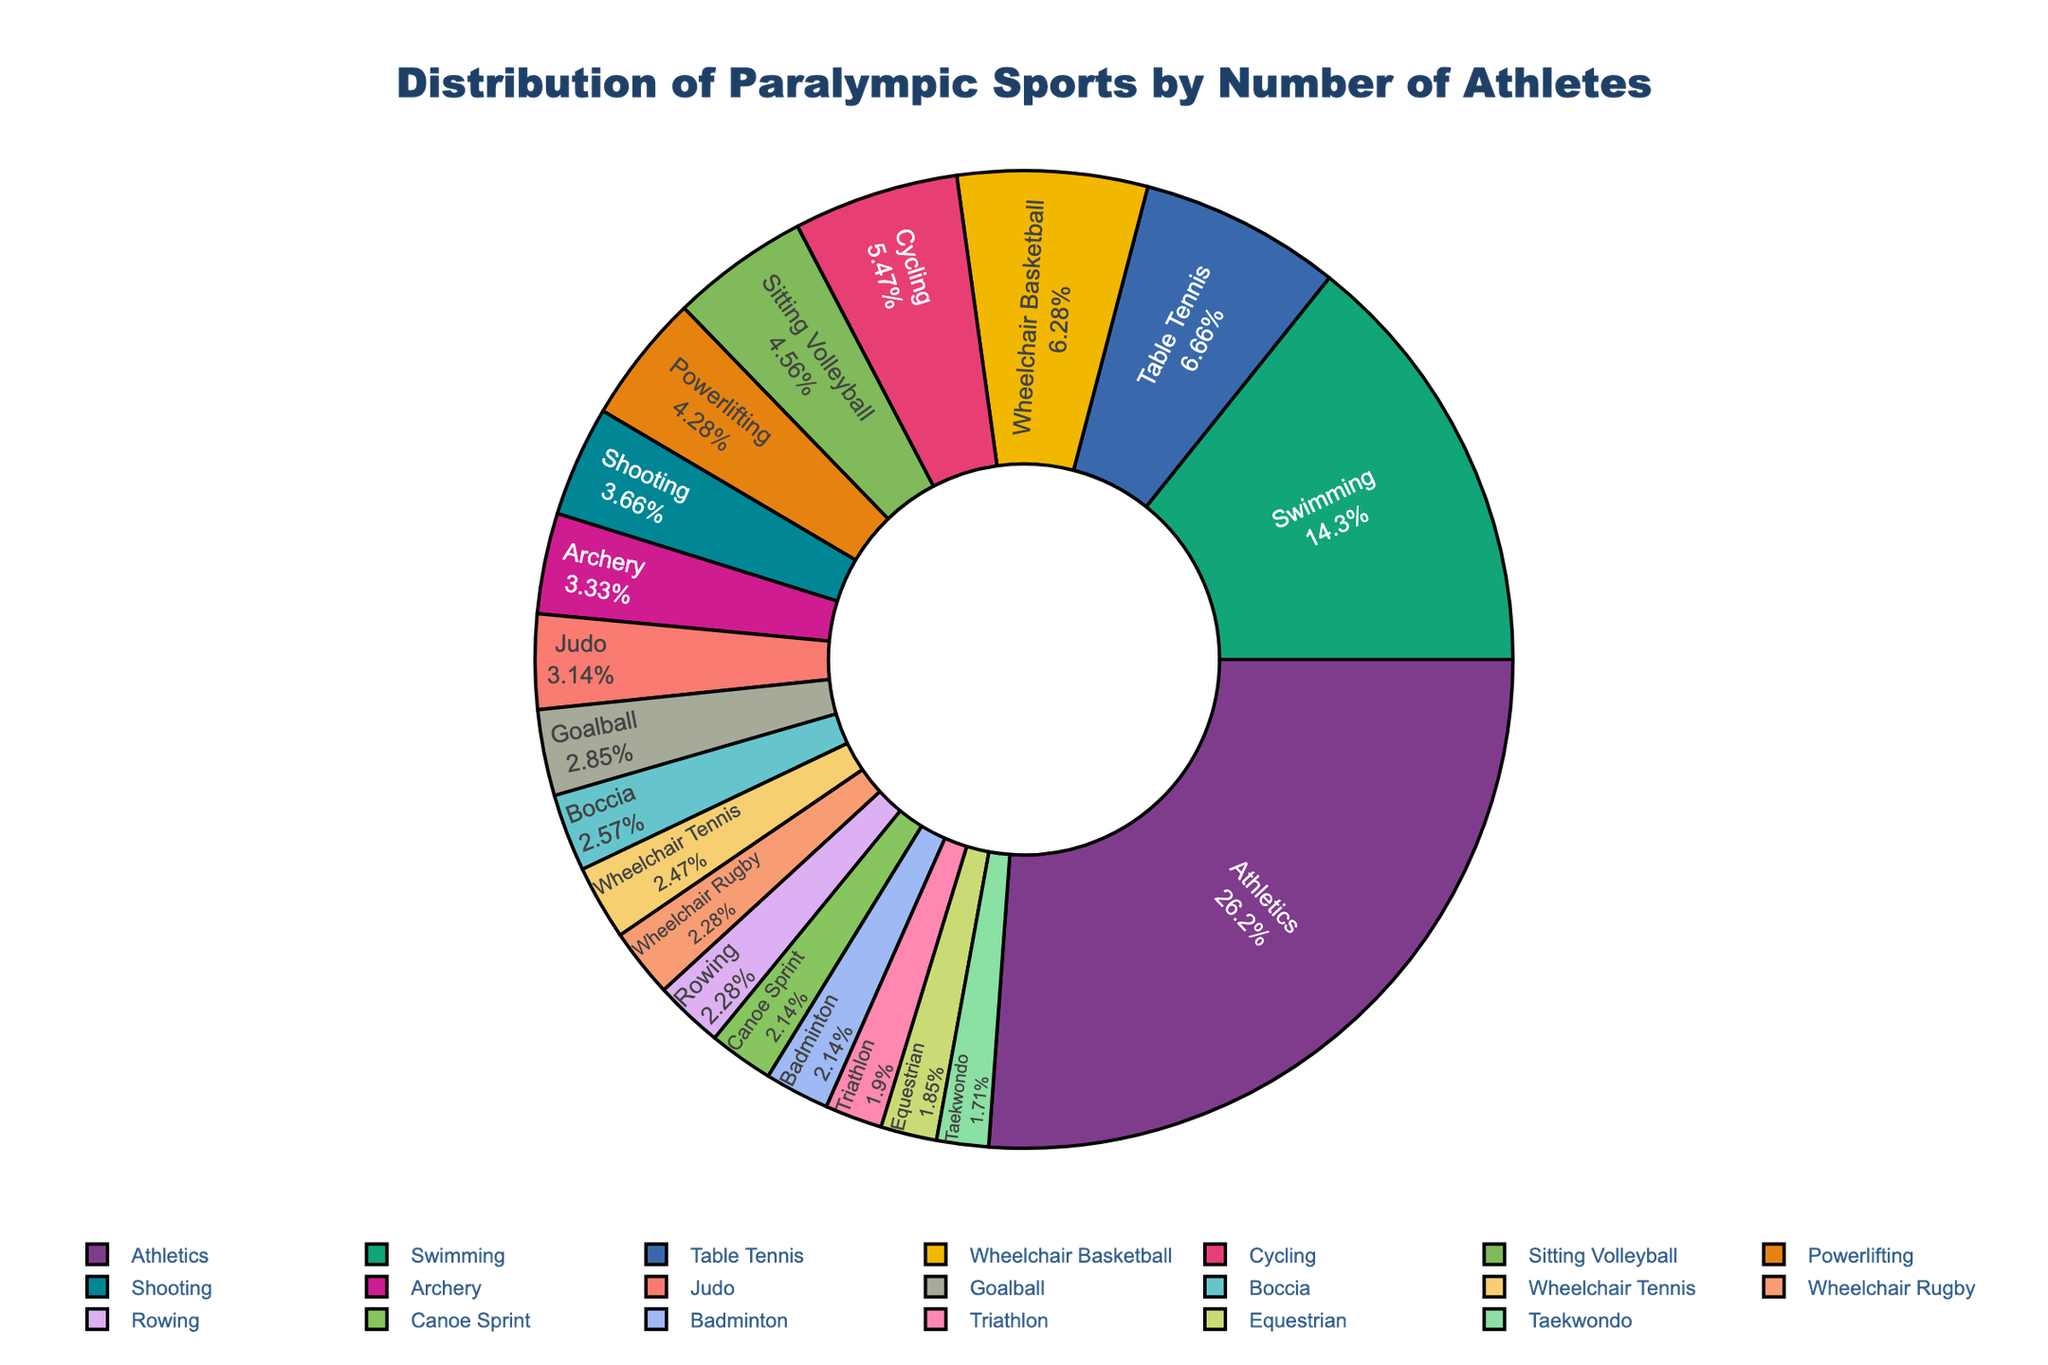what sport has the largest number of athletes? The largest segment in the pie chart represents Athletics. The label inside indicates that Athletics has the highest percentage of athletes among all sports.
Answer: Athletics which two sports have the smallest number of athletes? The smallest segments in the pie chart are represented by Taekwondo and Equestrian, both showing the lowest percentages.
Answer: Taekwondo and Equestrian What percentage of athletes are in Swimming? The pie chart shows an inside label for Swimming which includes both the name of the sport and its corresponding percentage of athletes. The inner segment shows Swimming's share of the total number of athletes.
Answer: 600 How does the number of athletes in Powerlifting compare to that in Wheelchair Tennis? The pie chart segments for Powerlifting and Wheelchair Tennis can be compared visually. Powerlifting has a larger segment than Wheelchair Tennis, indicating that it has more athletes.
Answer: Powerlifting has more athletes than Wheelchair Tennis Which category has a yellow segment, and what is its number of athletes? The pie chart features various colored segments. The yellow segment represents Table Tennis. The label inside the yellow portion shows the number of athletes in Table Tennis.
Answer: Table Tennis, 280 What's the combined percentage of athletes in Athletics and Swimming? Both Athletics and Swimming have their percentages labeled inside the pie chart. To get the combined percentage, add the percentages shown for each sport within their respective segments.
Answer: The sum of the segments for Athletics and Swimming: Athletics (1100) + Swimming (600) is 1700 Is Archery more or less popular than Powerlifting in terms of athlete numbers? Comparing the size of the segments for Archery and Powerlifting in the pie chart, it is clear that Archery has a smaller segment than Powerlifting, indicating fewer athletes.
Answer: Archery is less popular than Powerlifting What is the predominant color of the Athletics segment? The largest segment in the pie chart is for Athletics. Observing its color within the chart provides this information.
Answer: red 